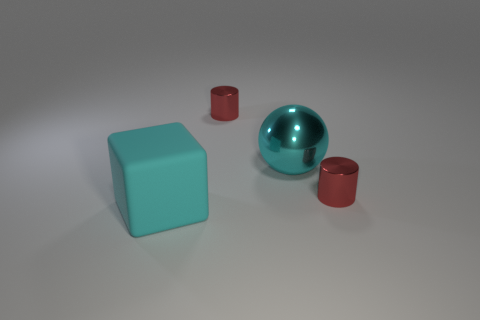If this image were part of an advertisement, what product do you think it's likely to represent? Given the simplicity and the clean aesthetic of the image, it could be part of an advertisement for a high-end home decor or an organization system promoting minimalism and order. The geometric shapes and polished surfaces imply a modern, design-focused product line. 